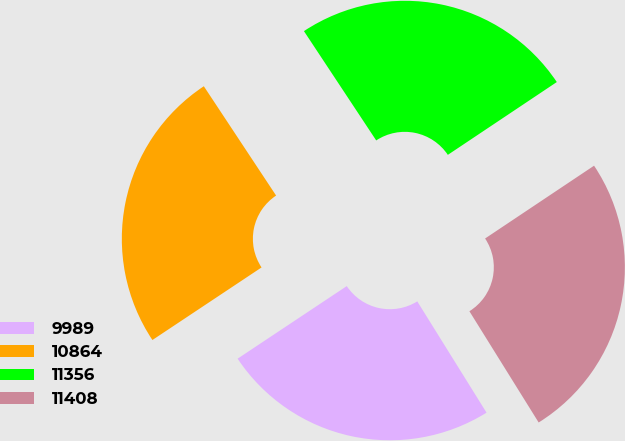Convert chart to OTSL. <chart><loc_0><loc_0><loc_500><loc_500><pie_chart><fcel>9989<fcel>10864<fcel>11356<fcel>11408<nl><fcel>24.52%<fcel>25.04%<fcel>24.92%<fcel>25.51%<nl></chart> 